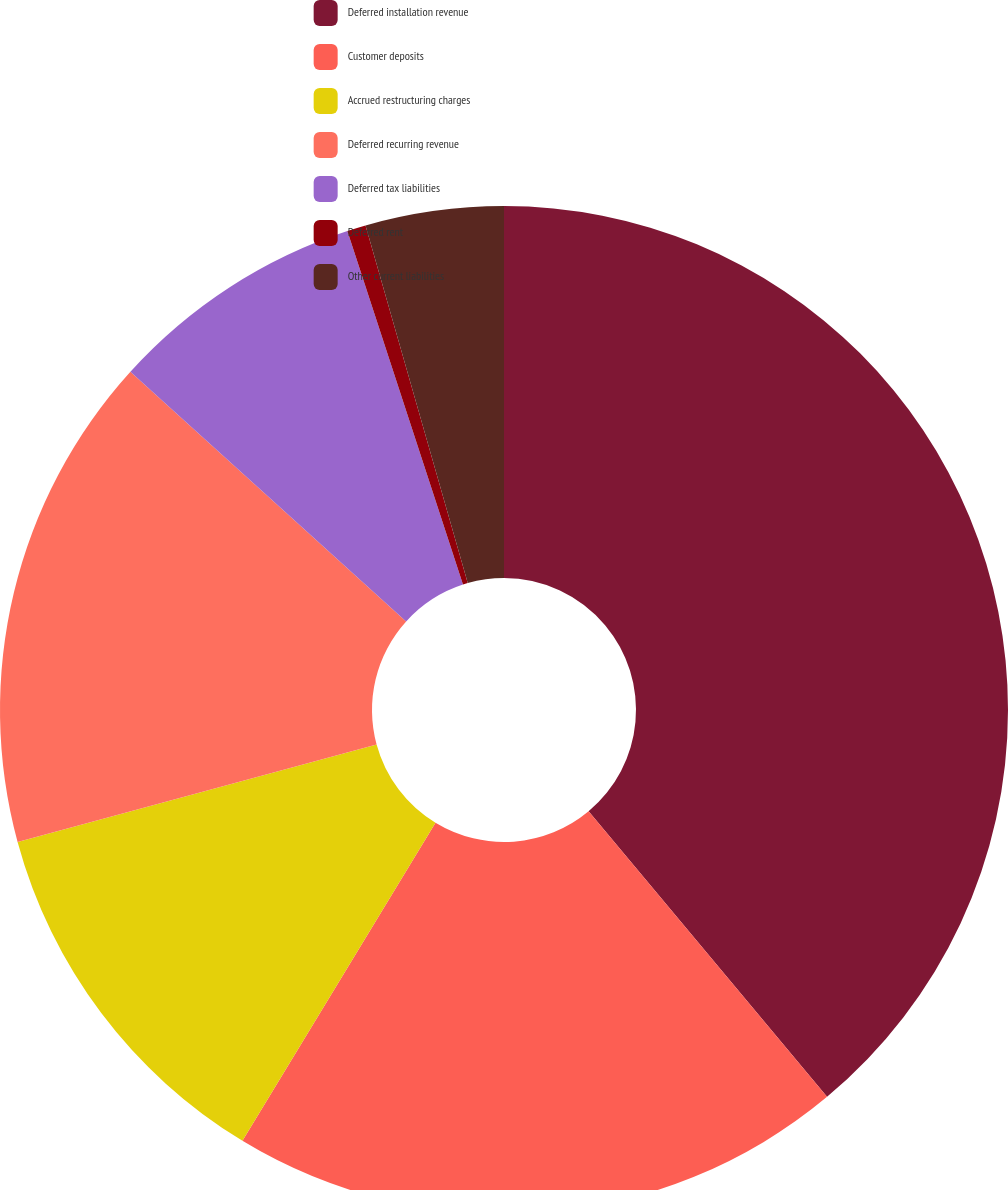<chart> <loc_0><loc_0><loc_500><loc_500><pie_chart><fcel>Deferred installation revenue<fcel>Customer deposits<fcel>Accrued restructuring charges<fcel>Deferred recurring revenue<fcel>Deferred tax liabilities<fcel>Deferred rent<fcel>Other current liabilities<nl><fcel>38.93%<fcel>19.76%<fcel>12.1%<fcel>15.93%<fcel>8.26%<fcel>0.6%<fcel>4.43%<nl></chart> 